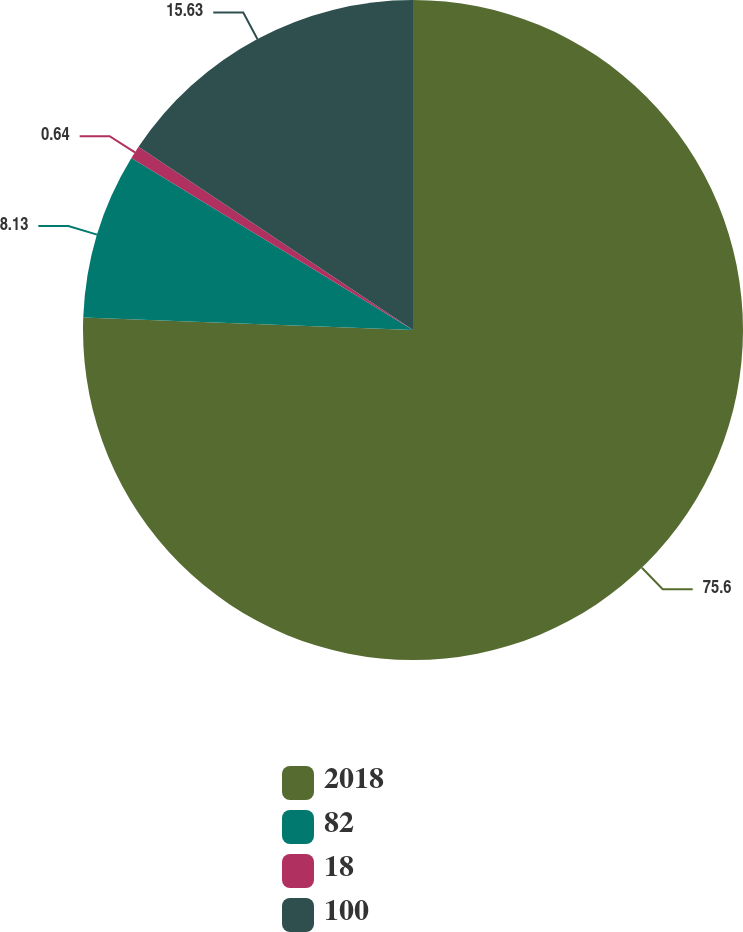<chart> <loc_0><loc_0><loc_500><loc_500><pie_chart><fcel>2018<fcel>82<fcel>18<fcel>100<nl><fcel>75.6%<fcel>8.13%<fcel>0.64%<fcel>15.63%<nl></chart> 